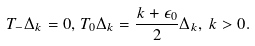<formula> <loc_0><loc_0><loc_500><loc_500>T _ { - } \Delta _ { k } = 0 , \, T _ { 0 } \Delta _ { k } = \frac { k + \epsilon _ { 0 } } { 2 } \Delta _ { k } , \, k > 0 .</formula> 